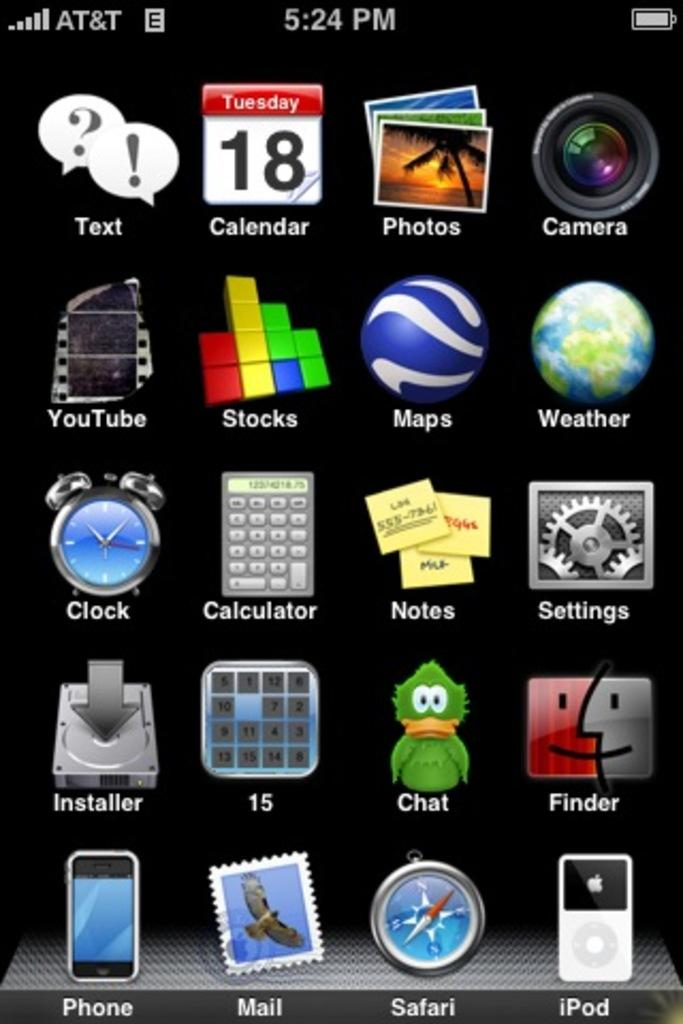Provide a one-sentence caption for the provided image. A screenshot from an AT&T smart phone showing it to be 5:24 pm. 